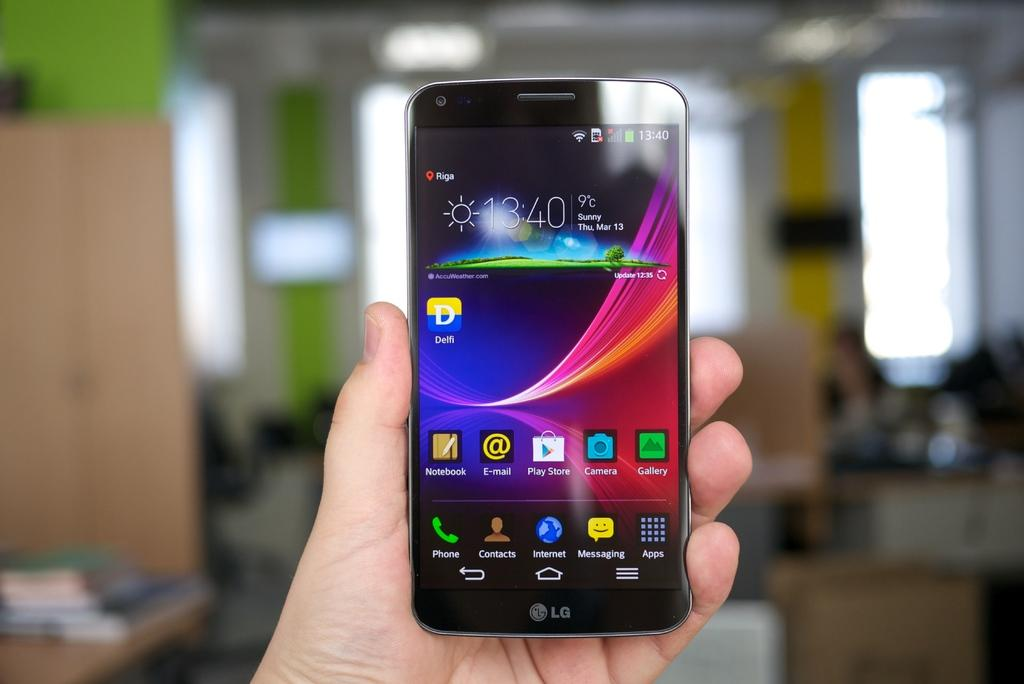<image>
Write a terse but informative summary of the picture. A person holds up an LG brand cell phone. 